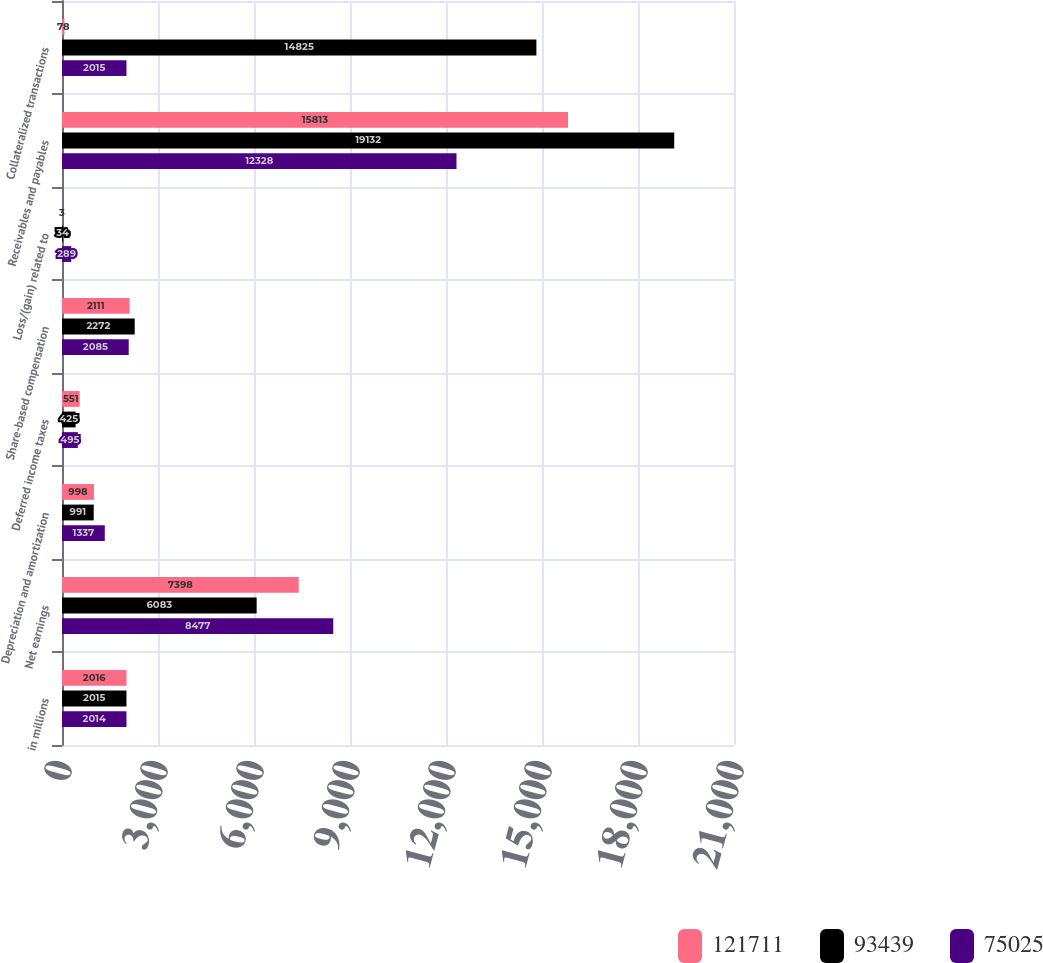<chart> <loc_0><loc_0><loc_500><loc_500><stacked_bar_chart><ecel><fcel>in millions<fcel>Net earnings<fcel>Depreciation and amortization<fcel>Deferred income taxes<fcel>Share-based compensation<fcel>Loss/(gain) related to<fcel>Receivables and payables<fcel>Collateralized transactions<nl><fcel>121711<fcel>2016<fcel>7398<fcel>998<fcel>551<fcel>2111<fcel>3<fcel>15813<fcel>78<nl><fcel>93439<fcel>2015<fcel>6083<fcel>991<fcel>425<fcel>2272<fcel>34<fcel>19132<fcel>14825<nl><fcel>75025<fcel>2014<fcel>8477<fcel>1337<fcel>495<fcel>2085<fcel>289<fcel>12328<fcel>2015<nl></chart> 